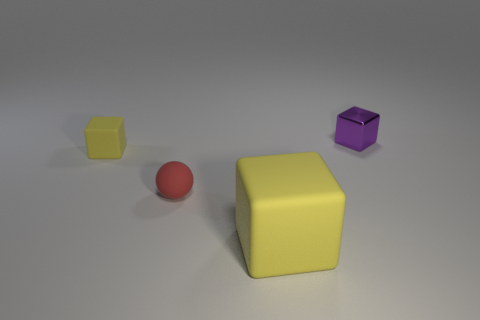Do the big cube and the tiny matte cube have the same color?
Ensure brevity in your answer.  Yes. What number of large yellow metal objects are there?
Offer a very short reply. 0. How many tiny purple cubes have the same material as the ball?
Your response must be concise. 0. What is the size of the other yellow thing that is the same shape as the small yellow object?
Provide a succinct answer. Large. What is the purple block made of?
Ensure brevity in your answer.  Metal. The small block that is to the right of the yellow cube in front of the tiny block that is on the left side of the purple object is made of what material?
Offer a terse response. Metal. Is there any other thing that is the same shape as the tiny yellow rubber thing?
Your response must be concise. Yes. What color is the large object that is the same shape as the tiny purple thing?
Ensure brevity in your answer.  Yellow. Is the color of the matte block right of the small yellow rubber block the same as the tiny block on the left side of the tiny metal cube?
Give a very brief answer. Yes. Is the number of purple shiny blocks that are in front of the sphere greater than the number of tiny yellow cubes?
Offer a terse response. No. 